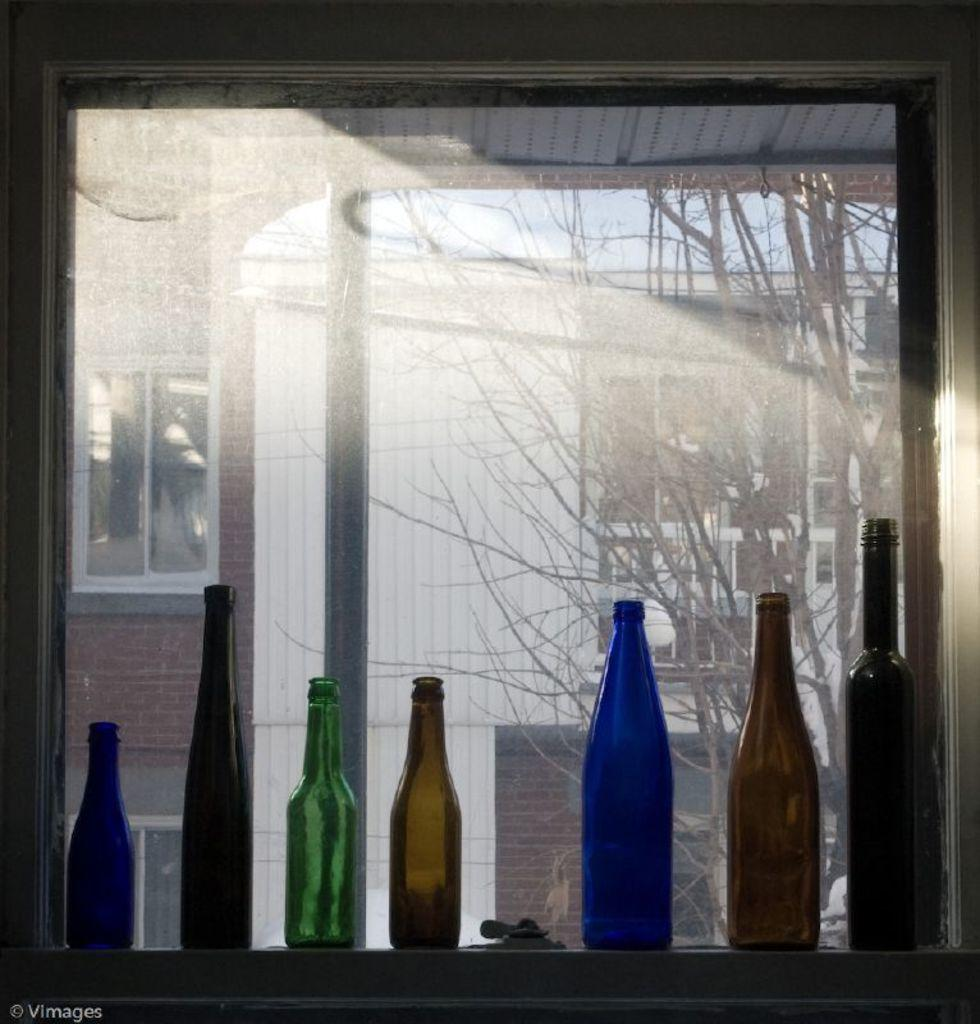What objects are near the window in the image? There are bottles near the window in the image. What can be seen outside the window? A building and a bare tree are visible from the window. What game is being played on the fifth floor of the building visible from the window? There is no information about a game being played on the fifth floor of the building visible from the window, as the image only shows the exterior of the building. 